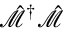Convert formula to latex. <formula><loc_0><loc_0><loc_500><loc_500>\hat { \mathcal { M } } ^ { \dagger } \hat { \mathcal { M } }</formula> 